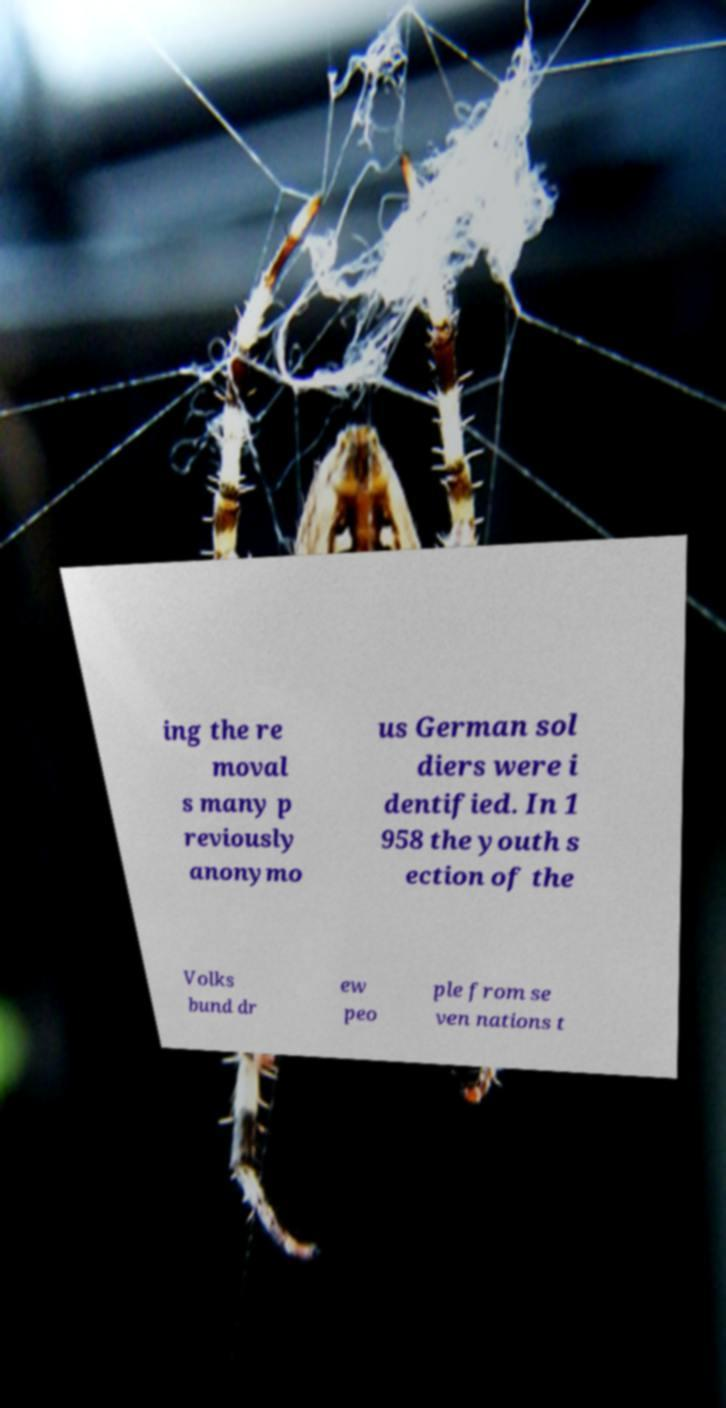Please read and relay the text visible in this image. What does it say? ing the re moval s many p reviously anonymo us German sol diers were i dentified. In 1 958 the youth s ection of the Volks bund dr ew peo ple from se ven nations t 